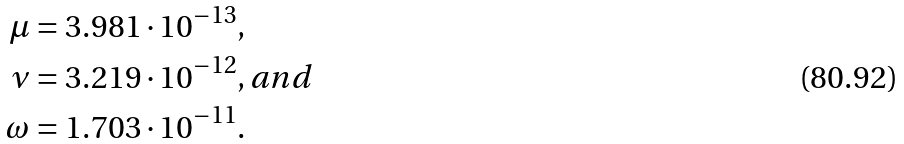Convert formula to latex. <formula><loc_0><loc_0><loc_500><loc_500>\mu & = 3 . 9 8 1 \cdot 1 0 ^ { - 1 3 } , \\ \nu & = 3 . 2 1 9 \cdot 1 0 ^ { - 1 2 } , a n d \\ \omega & = 1 . 7 0 3 \cdot 1 0 ^ { - 1 1 } .</formula> 